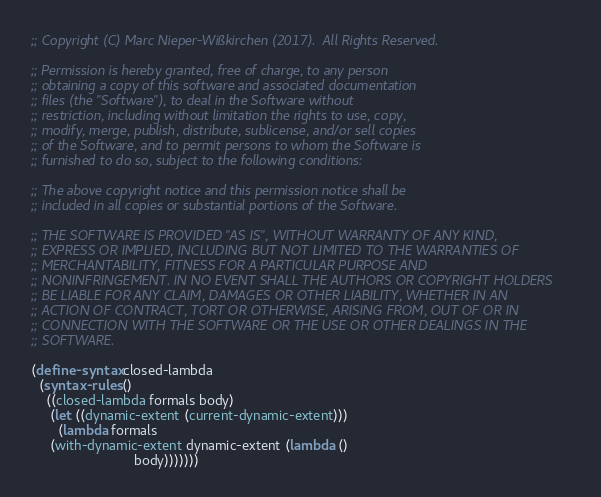Convert code to text. <code><loc_0><loc_0><loc_500><loc_500><_Scheme_>;; Copyright (C) Marc Nieper-Wißkirchen (2017).  All Rights Reserved.

;; Permission is hereby granted, free of charge, to any person
;; obtaining a copy of this software and associated documentation
;; files (the "Software"), to deal in the Software without
;; restriction, including without limitation the rights to use, copy,
;; modify, merge, publish, distribute, sublicense, and/or sell copies
;; of the Software, and to permit persons to whom the Software is
;; furnished to do so, subject to the following conditions:

;; The above copyright notice and this permission notice shall be
;; included in all copies or substantial portions of the Software.

;; THE SOFTWARE IS PROVIDED "AS IS", WITHOUT WARRANTY OF ANY KIND,
;; EXPRESS OR IMPLIED, INCLUDING BUT NOT LIMITED TO THE WARRANTIES OF
;; MERCHANTABILITY, FITNESS FOR A PARTICULAR PURPOSE AND
;; NONINFRINGEMENT. IN NO EVENT SHALL THE AUTHORS OR COPYRIGHT HOLDERS
;; BE LIABLE FOR ANY CLAIM, DAMAGES OR OTHER LIABILITY, WHETHER IN AN
;; ACTION OF CONTRACT, TORT OR OTHERWISE, ARISING FROM, OUT OF OR IN
;; CONNECTION WITH THE SOFTWARE OR THE USE OR OTHER DEALINGS IN THE
;; SOFTWARE.

(define-syntax closed-lambda
  (syntax-rules ()
    ((closed-lambda formals body)
     (let ((dynamic-extent (current-dynamic-extent)))
       (lambda formals
	 (with-dynamic-extent dynamic-extent (lambda ()
					       body)))))))
</code> 